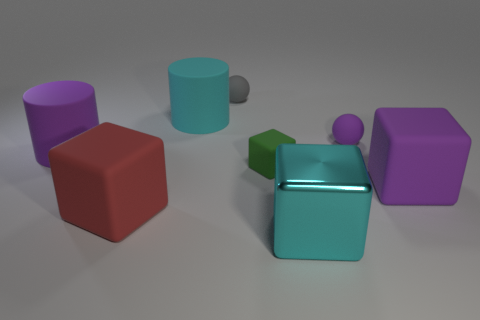Is the small green cube made of the same material as the large cylinder that is on the left side of the large red matte block?
Offer a terse response. Yes. What is the small green object made of?
Provide a succinct answer. Rubber. There is another object that is the same color as the big shiny thing; what material is it?
Provide a short and direct response. Rubber. How many other things are there of the same material as the green object?
Make the answer very short. 6. There is a purple rubber object that is both to the right of the red rubber object and behind the purple cube; what shape is it?
Your answer should be very brief. Sphere. There is a ball that is made of the same material as the tiny purple thing; what color is it?
Your answer should be compact. Gray. Are there an equal number of green objects that are behind the small green rubber thing and blue shiny cubes?
Give a very brief answer. Yes. What shape is the metallic thing that is the same size as the red rubber thing?
Ensure brevity in your answer.  Cube. What number of other objects are the same shape as the big metallic thing?
Your answer should be compact. 3. There is a red block; does it have the same size as the cylinder that is on the left side of the big cyan matte cylinder?
Your response must be concise. Yes. 